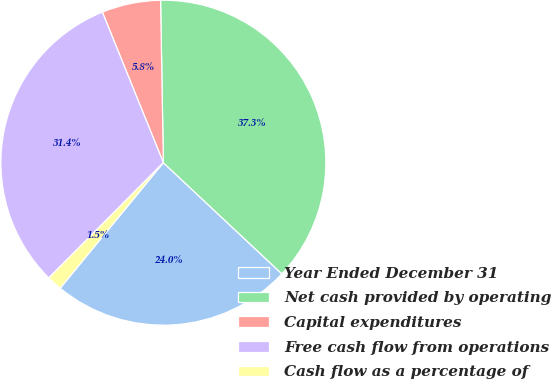Convert chart. <chart><loc_0><loc_0><loc_500><loc_500><pie_chart><fcel>Year Ended December 31<fcel>Net cash provided by operating<fcel>Capital expenditures<fcel>Free cash flow from operations<fcel>Cash flow as a percentage of<nl><fcel>23.96%<fcel>37.27%<fcel>5.85%<fcel>31.42%<fcel>1.5%<nl></chart> 